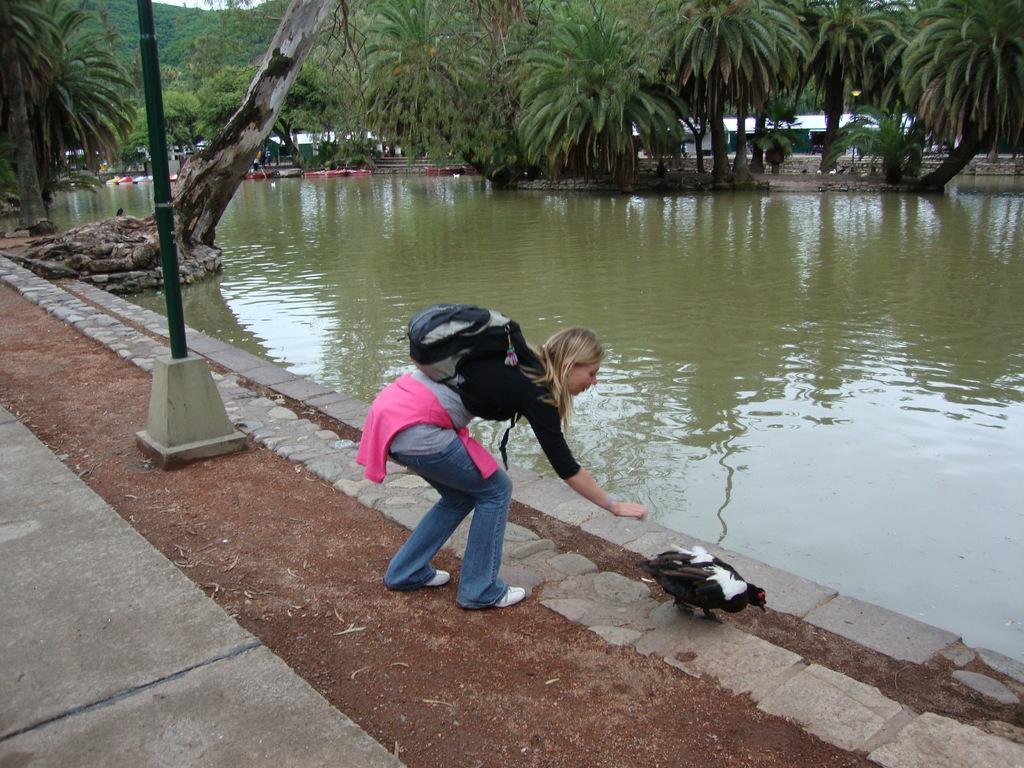Can you describe this image briefly? In this image, I can see a bird and a woman is standing on the pathway. There are water and trees. On the left side of the image, I can see a pole. Behind the trees, I can see the houses. 